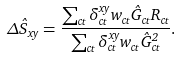<formula> <loc_0><loc_0><loc_500><loc_500>\Delta \hat { S } _ { x y } = \frac { \sum _ { c t } \delta _ { c t } ^ { x y } w _ { c t } \hat { G } _ { c t } R _ { c t } } { \sum _ { c t } \delta _ { c t } ^ { x y } w _ { c t } \hat { G } _ { c t } ^ { 2 } } .</formula> 